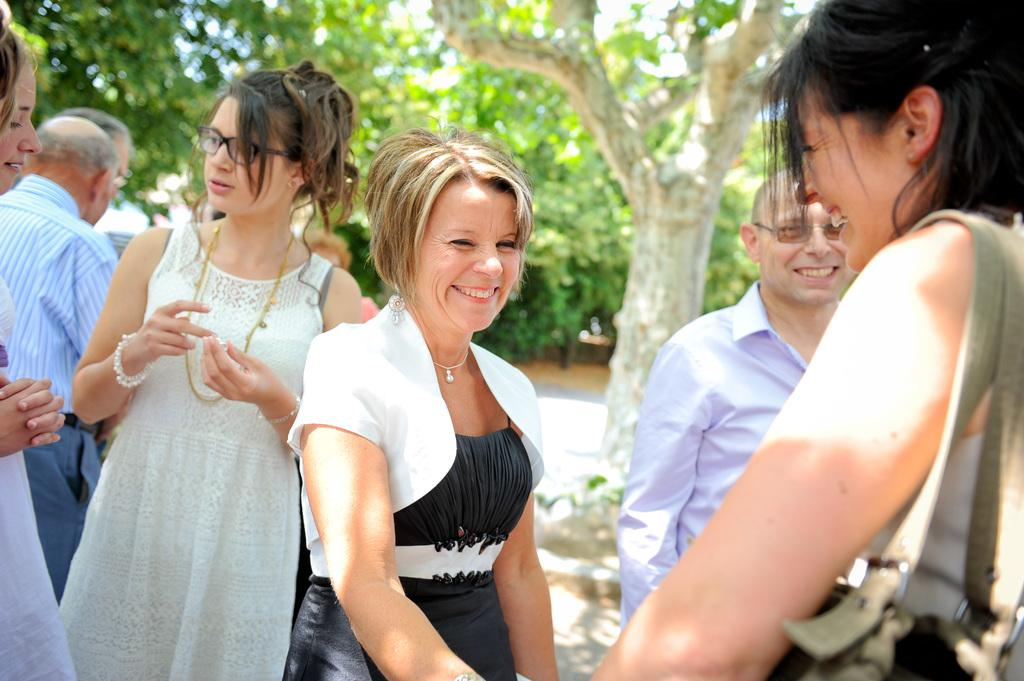What are the people in the image doing? The people in the image are standing on the ground. Can you describe the expressions of the people in the image? Some of the people are smiling. What can be seen in the background of the image? There are trees in the background of the image. How would you describe the quality of the background in the image? The background of the image is blurred. What type of reaction does the band receive from the audience in the image? There is no band present in the image, so it is not possible to determine the audience's reaction to a band. 